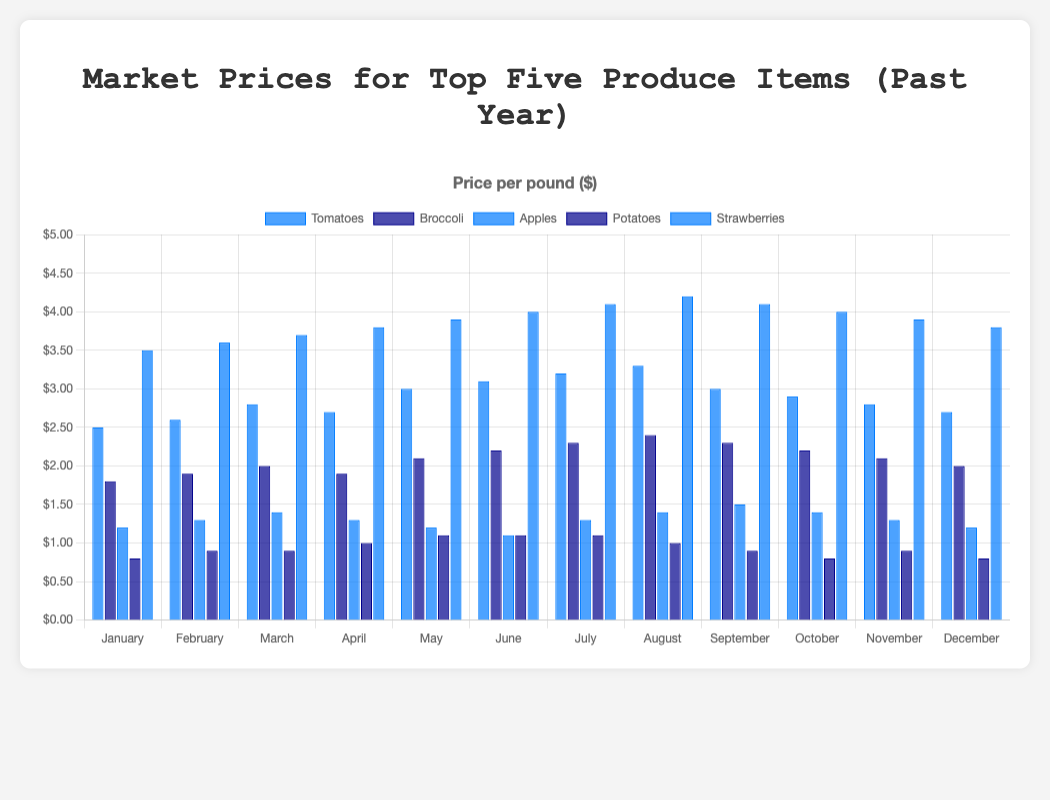Which produce item had the highest price in July? The bar heights indicate the prices, and the highest bar in July belongs to Strawberries. The price is 4.1 dollars per pound.
Answer: Strawberries Which month did Tomatoes reach their peak price? To find this, look for the tallest bar in the series for Tomatoes. The peak price occurs in August, where Tomatoes are priced at 3.3 dollars per pound.
Answer: August Is Broccoli cheaper in January or November? Compare the bar heights for Broccoli in January and November. The January price (1.8 dollars) is lower than the November price (2.1 dollars).
Answer: January What is the average price of Apples in the first quarter of the year? Look at the prices for January ($1.2), February ($1.3), and March ($1.4). The sum is 1.2 + 1.3 + 1.4 = 3.9. The average is 3.9 / 3 = 1.3 dollars.
Answer: 1.3 dollars Which produce item saw the most significant price increase from January to December? Calculate the difference in price from January to December for each item and compare. Strawberries increased from 3.5 to 3.8 dollars (an increase of 0.3), while Tomatoes decreased from 2.5 to 2.7 (an increase of 0.2), Broccoli from 1.8 to 2.0 (an increase of 0.2), and Apples remained the same. Therefore, Strawberry had the most significant increase from January to December by 0.3 dollars.
Answer: Strawberries Did any item's price decrease from July to December? Compare the prices in July and December. Tomatoes decreased from 3.2 to 2.7, Broccoli from 2.3 to 2.0, and Apples also decreased. This shows that all items, except Strawberries, showed a price decrease.
Answer: Yes, Tomatoes, Broccoli, Apples, Potatoes What was the average price of all produce items in September? Add up the prices for September and divide by five: (3 + 2.3 + 1.5 + 0.9 + 4.1) / 5 = 11.8 / 5 = 2.36 dollars.
Answer: 2.36 dollars Which produce item was the cheapest in May? Look at the bar heights for May. Potatoes, with the lowest bar, are priced at 1.1 dollars in May.
Answer: Potatoes Among the five produce items, which one had the most stable price throughout the months? Compare the variation in heights of the bars for each produce item across all months. Apples have the smallest changes in bar height, indicating the most stable prices.
Answer: Apples During which month do we see the highest overall prices among all items? Sum up all the prices for each month and find the highest total. July's total is the highest: (3.2 + 2.3 + 1.3 + 1.1 + 4.1) = 12.0 dollars.
Answer: July 